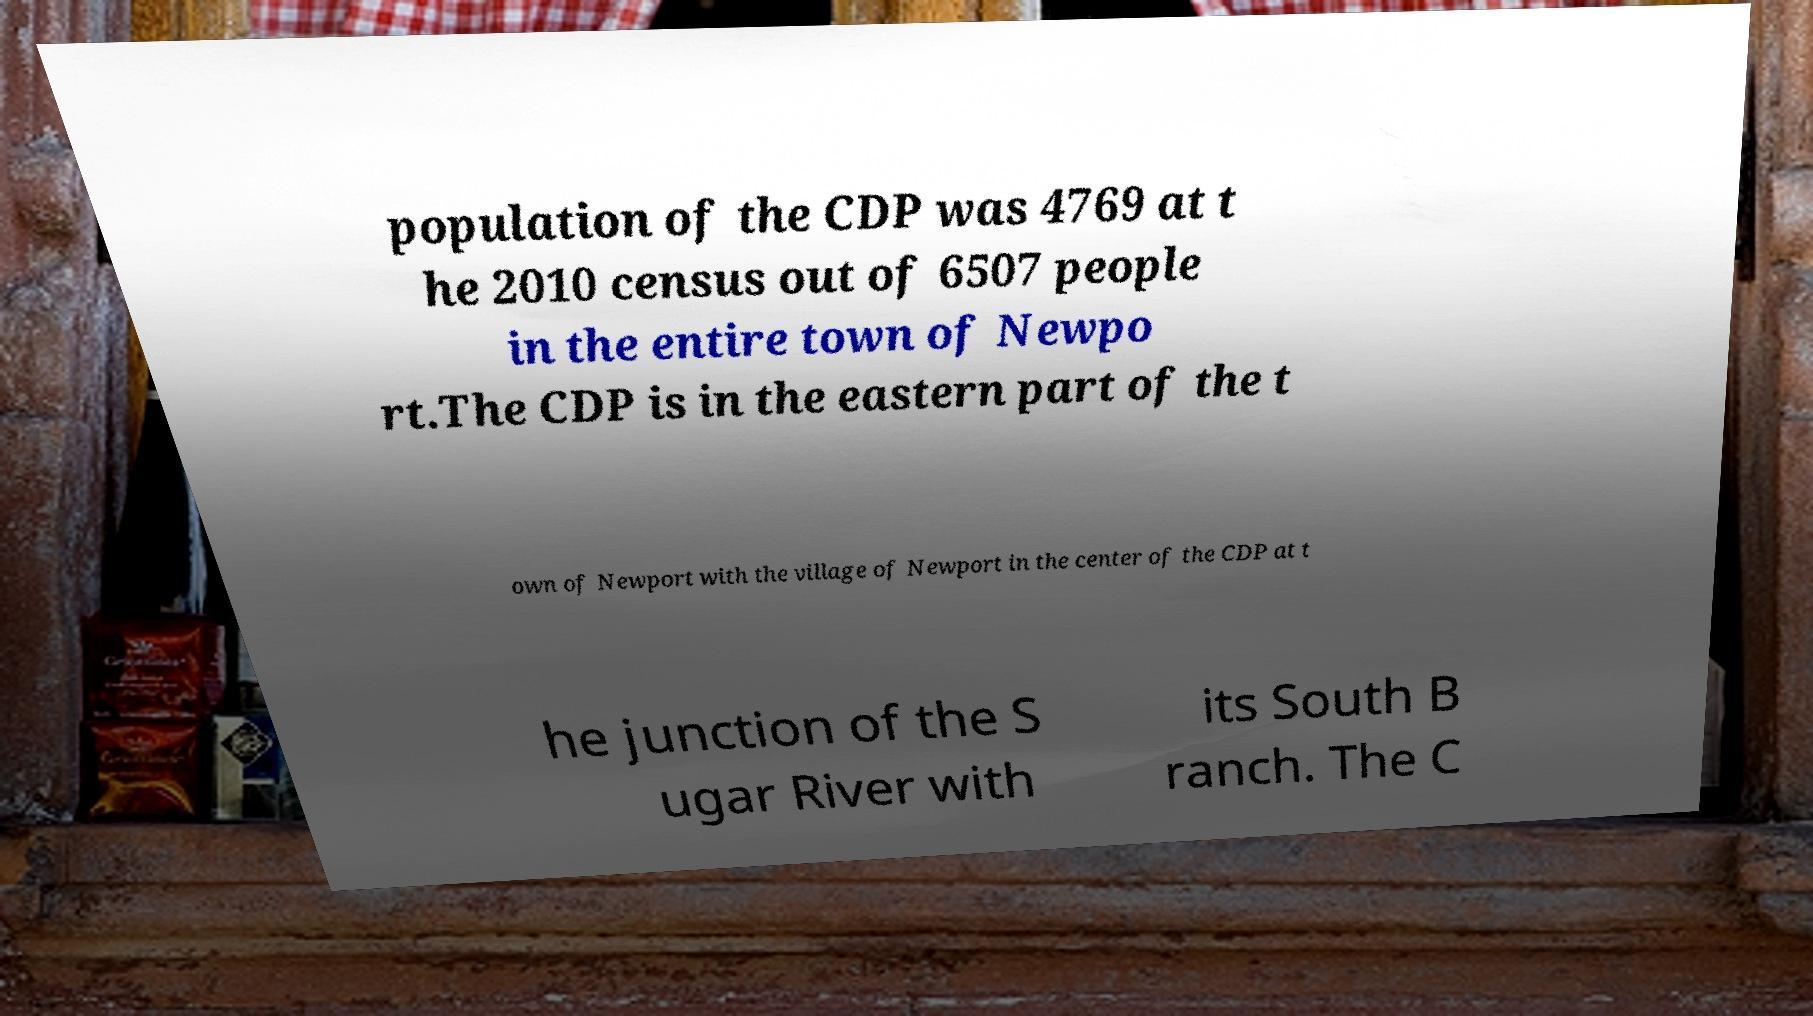There's text embedded in this image that I need extracted. Can you transcribe it verbatim? population of the CDP was 4769 at t he 2010 census out of 6507 people in the entire town of Newpo rt.The CDP is in the eastern part of the t own of Newport with the village of Newport in the center of the CDP at t he junction of the S ugar River with its South B ranch. The C 